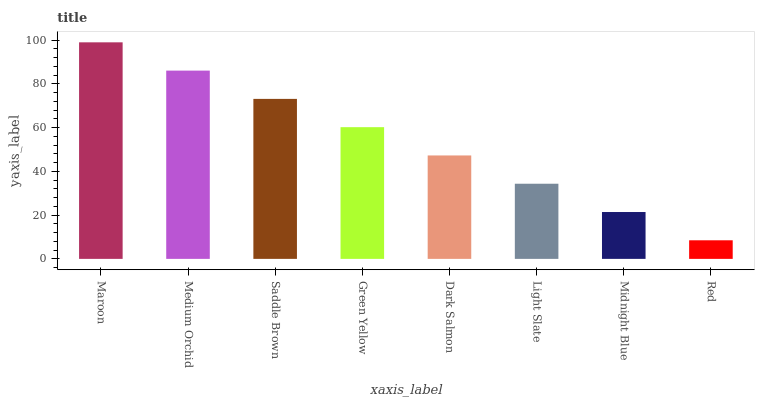Is Medium Orchid the minimum?
Answer yes or no. No. Is Medium Orchid the maximum?
Answer yes or no. No. Is Maroon greater than Medium Orchid?
Answer yes or no. Yes. Is Medium Orchid less than Maroon?
Answer yes or no. Yes. Is Medium Orchid greater than Maroon?
Answer yes or no. No. Is Maroon less than Medium Orchid?
Answer yes or no. No. Is Green Yellow the high median?
Answer yes or no. Yes. Is Dark Salmon the low median?
Answer yes or no. Yes. Is Dark Salmon the high median?
Answer yes or no. No. Is Red the low median?
Answer yes or no. No. 